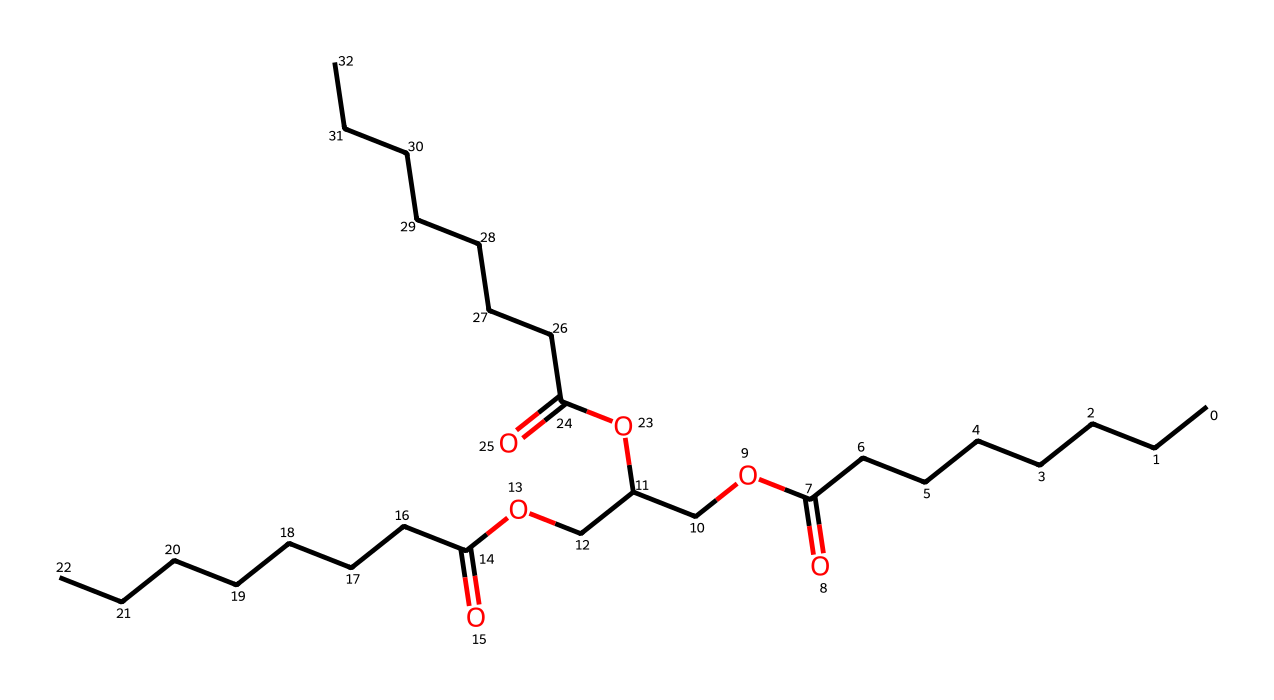What is the total number of carbon atoms in this lipid? By examining the SMILES structure, we can count the number of 'C' characters. The molecular structure includes several long carbon chains and branches. Each occurrence of 'C' represents a carbon atom, and we find a total of 24 carbon atoms in the entire structure.
Answer: 24 How many ester groups are present in this compound? The presence of ester groups can be identified by looking for the sequence "C(=O)O" in the SMILES representation. Counting these sequences leads us to find three ester groups in total.
Answer: 3 What is the general class of this chemical? This chemical is categorized under lipids, which are defined by their hydrophobic and amphiphilic properties. The presence of long carbon chains and ester functional groups supports this classification.
Answer: lipids How many distinct functional groups are present in this compound? A careful examination of the SMILES structure reveals the functional groups present: carboxylic acids and esters. There are two distinct types of functional groups identified in the structure.
Answer: 2 What is the molecular weight range typical for similar biodegradable lipids? Biodegradable lipid polymers similar to this structure typically exhibit molecular weights ranging from 500 to 2000 Da. This estimate considers the common sizes of polyesters and lipids, influenced by their chain length and branching.
Answer: 500-2000 Da What type of bonding predominates in this lipid? The SMILES representation indicates the presence of single and double bonds mainly due to carbon and oxygen. The predominant bond type in this lipid is covalent bonding, specially seen between carbon and oxygen within the ester groups.
Answer: covalent bonding 